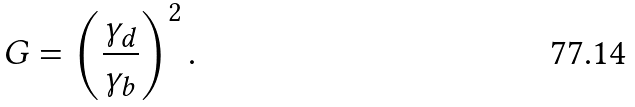<formula> <loc_0><loc_0><loc_500><loc_500>G = \left ( \frac { \gamma _ { d } } { \gamma _ { b } } \right ) ^ { 2 } .</formula> 